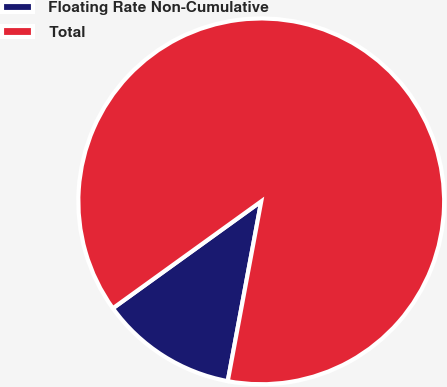Convert chart. <chart><loc_0><loc_0><loc_500><loc_500><pie_chart><fcel>Floating Rate Non-Cumulative<fcel>Total<nl><fcel>12.13%<fcel>87.87%<nl></chart> 